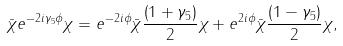<formula> <loc_0><loc_0><loc_500><loc_500>\bar { \chi } e ^ { - 2 i \gamma _ { 5 } \phi } \chi = e ^ { - 2 i \phi } \bar { \chi } \frac { \left ( 1 + \gamma _ { 5 } \right ) } { 2 } \chi + e ^ { 2 i \phi } \bar { \chi } \frac { \left ( 1 - \gamma _ { 5 } \right ) } { 2 } \chi ,</formula> 